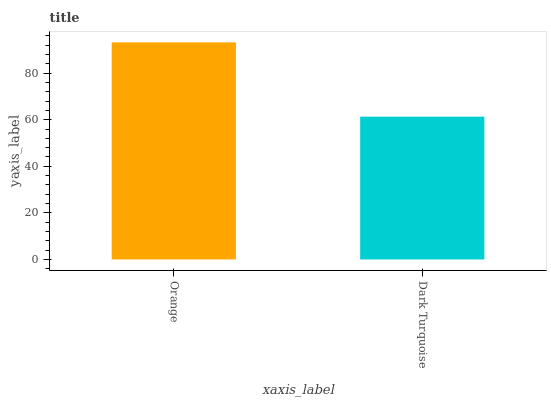Is Dark Turquoise the minimum?
Answer yes or no. Yes. Is Orange the maximum?
Answer yes or no. Yes. Is Dark Turquoise the maximum?
Answer yes or no. No. Is Orange greater than Dark Turquoise?
Answer yes or no. Yes. Is Dark Turquoise less than Orange?
Answer yes or no. Yes. Is Dark Turquoise greater than Orange?
Answer yes or no. No. Is Orange less than Dark Turquoise?
Answer yes or no. No. Is Orange the high median?
Answer yes or no. Yes. Is Dark Turquoise the low median?
Answer yes or no. Yes. Is Dark Turquoise the high median?
Answer yes or no. No. Is Orange the low median?
Answer yes or no. No. 